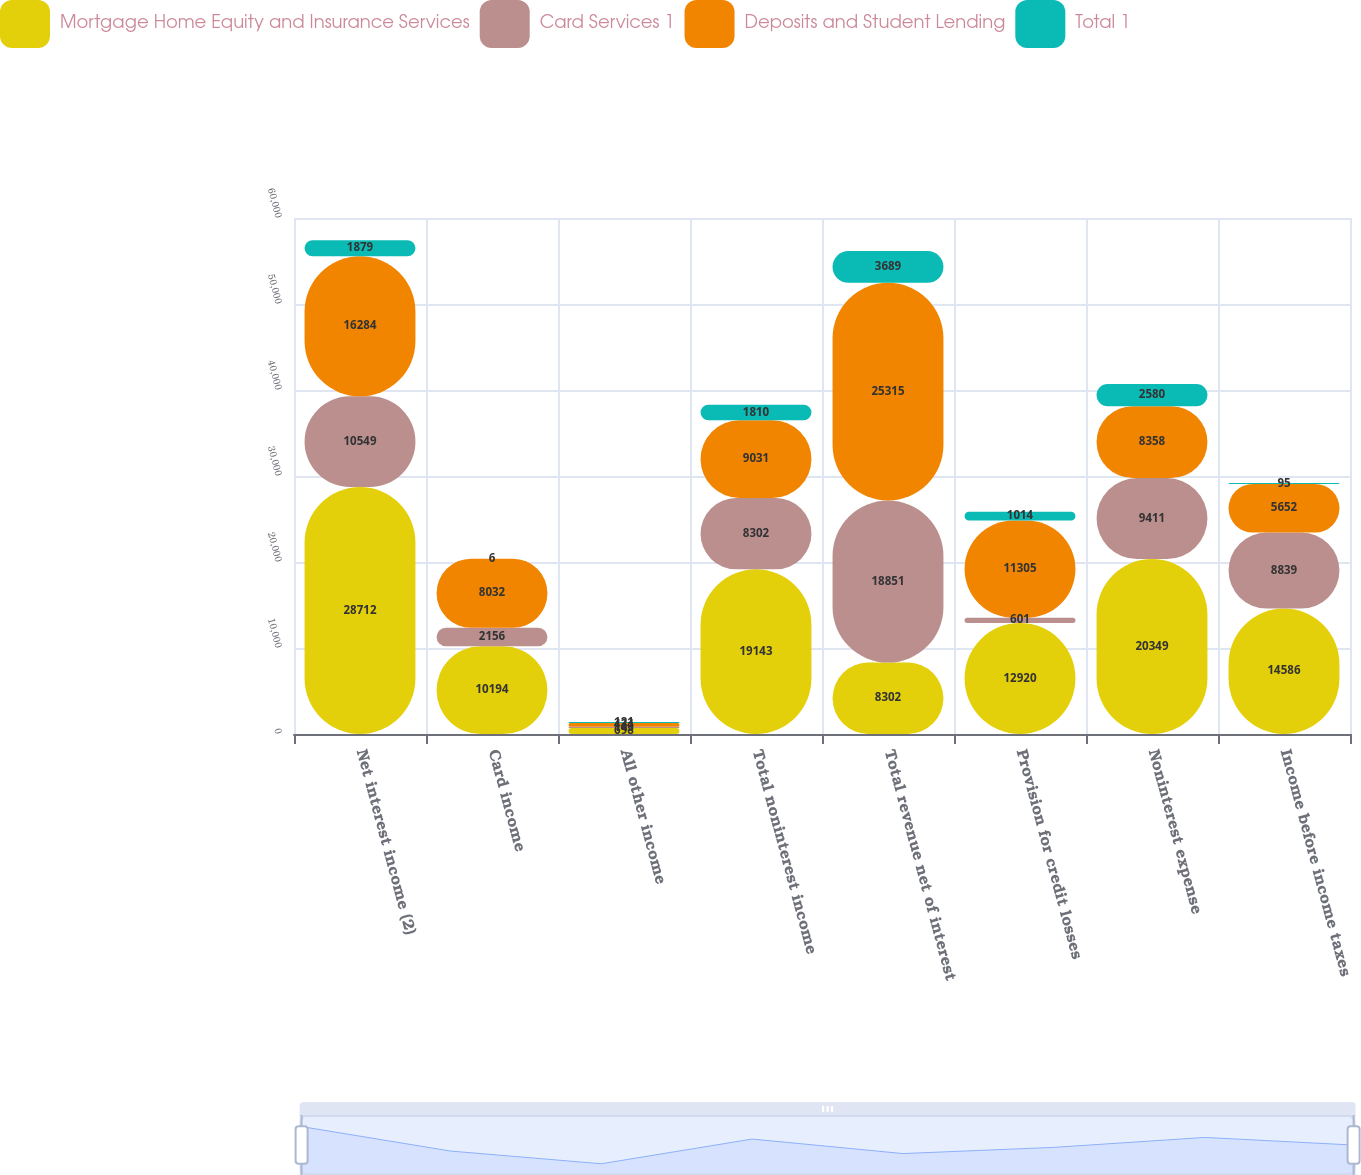Convert chart to OTSL. <chart><loc_0><loc_0><loc_500><loc_500><stacked_bar_chart><ecel><fcel>Net interest income (2)<fcel>Card income<fcel>All other income<fcel>Total noninterest income<fcel>Total revenue net of interest<fcel>Provision for credit losses<fcel>Noninterest expense<fcel>Income before income taxes<nl><fcel>Mortgage Home Equity and Insurance Services<fcel>28712<fcel>10194<fcel>698<fcel>19143<fcel>8302<fcel>12920<fcel>20349<fcel>14586<nl><fcel>Card Services 1<fcel>10549<fcel>2156<fcel>143<fcel>8302<fcel>18851<fcel>601<fcel>9411<fcel>8839<nl><fcel>Deposits and Student Lending<fcel>16284<fcel>8032<fcel>434<fcel>9031<fcel>25315<fcel>11305<fcel>8358<fcel>5652<nl><fcel>Total 1<fcel>1879<fcel>6<fcel>121<fcel>1810<fcel>3689<fcel>1014<fcel>2580<fcel>95<nl></chart> 